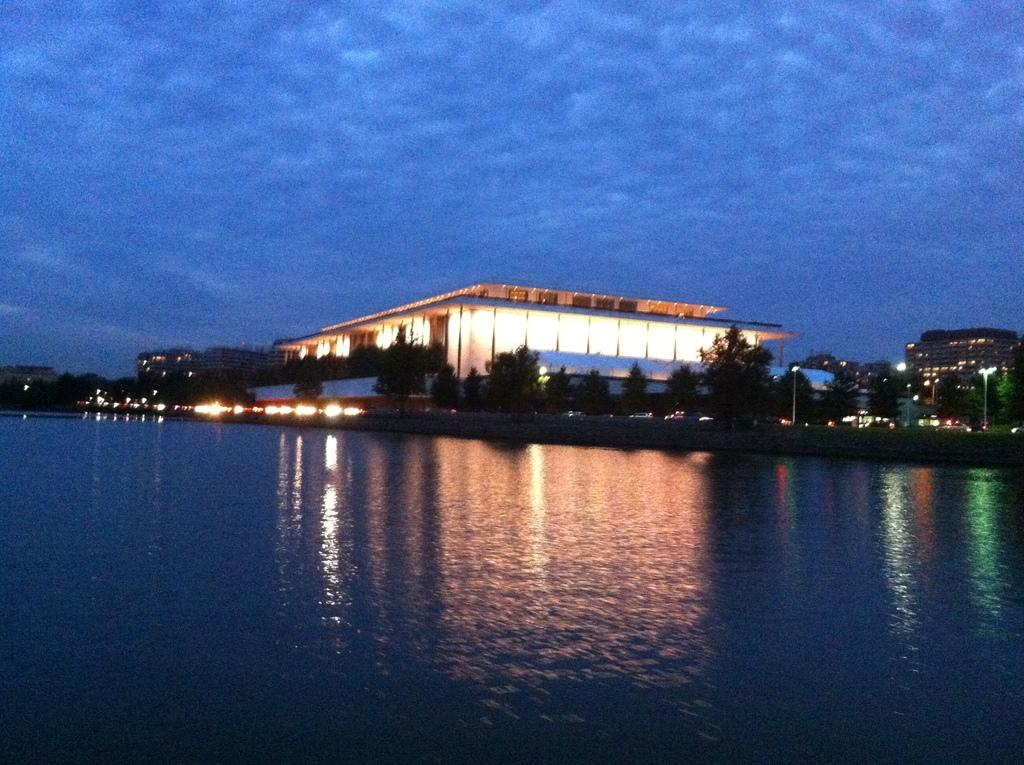What type of natural elements can be seen in the image? There are trees in the image. What artificial elements can be seen in the image? There are lights and buildings in the image. What is visible in the background of the image? The background of the image includes water and the sky. Where is the pail located in the image? There is no pail present in the image. What type of beast can be seen roaming in the background of the image? There is no beast present in the image; the background features water and the sky. 